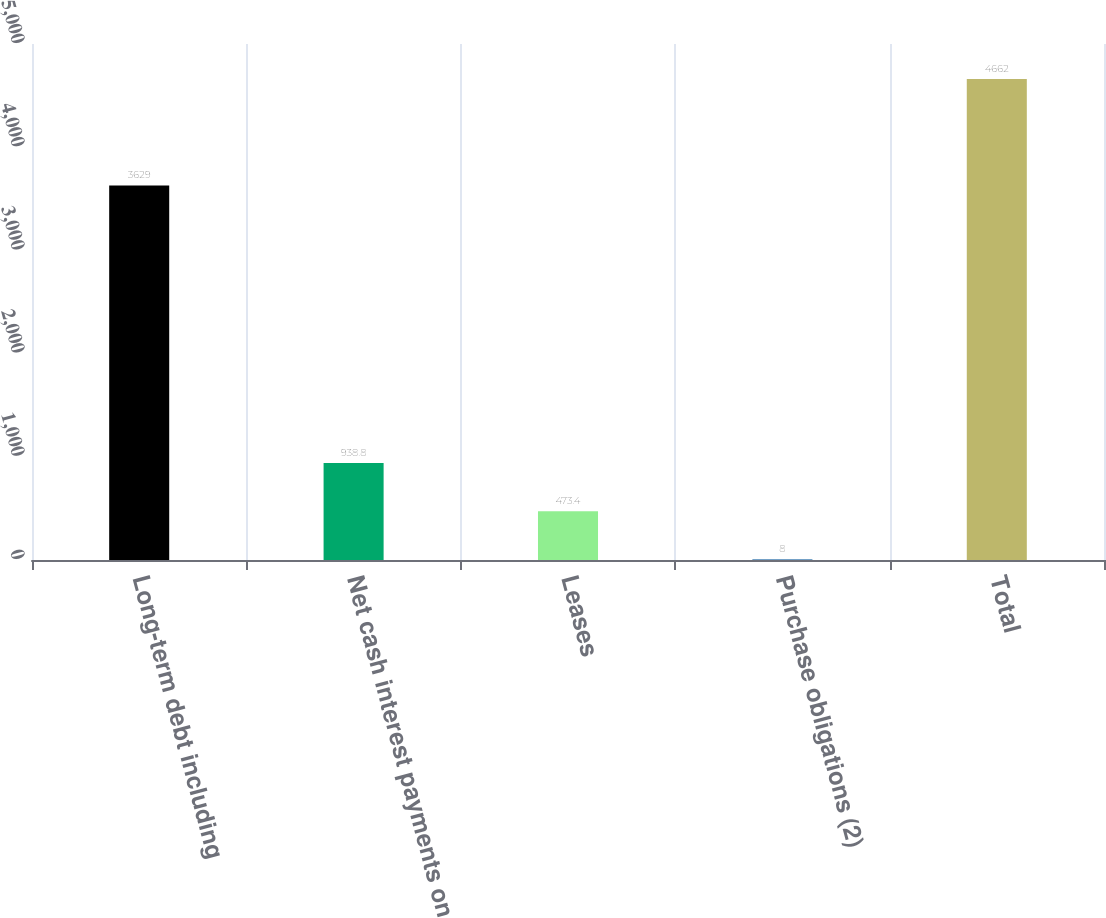<chart> <loc_0><loc_0><loc_500><loc_500><bar_chart><fcel>Long-term debt including<fcel>Net cash interest payments on<fcel>Leases<fcel>Purchase obligations (2)<fcel>Total<nl><fcel>3629<fcel>938.8<fcel>473.4<fcel>8<fcel>4662<nl></chart> 